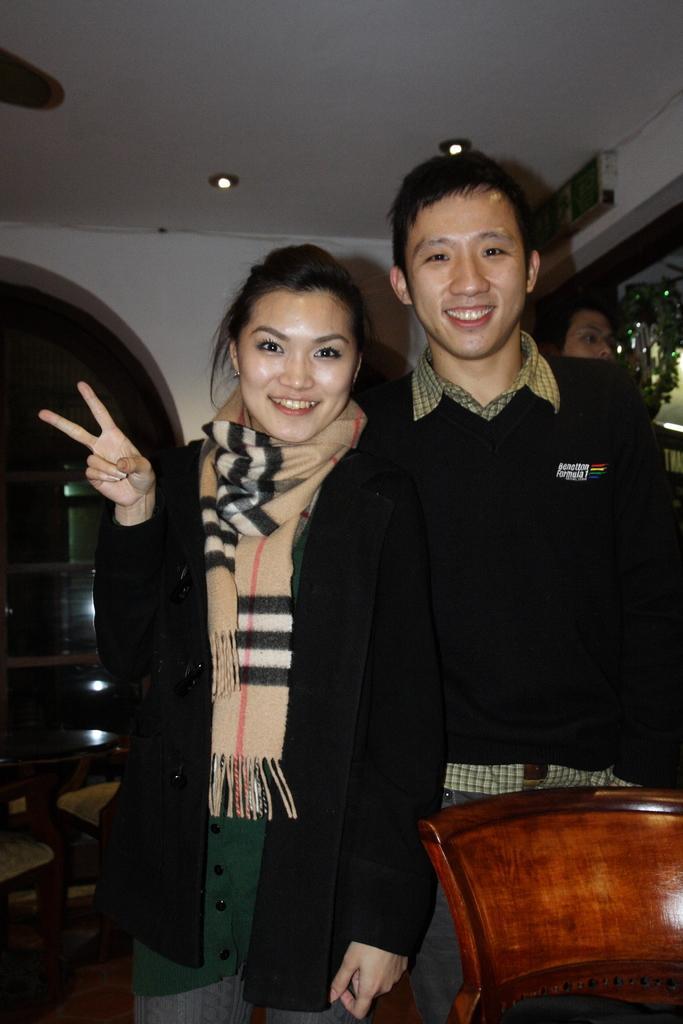Could you give a brief overview of what you see in this image? In this image in the center there are persons standing and smiling. In the front there is an object which is brown in colour. In the background there is a table and there are cars, there is a wall and there is a person. 